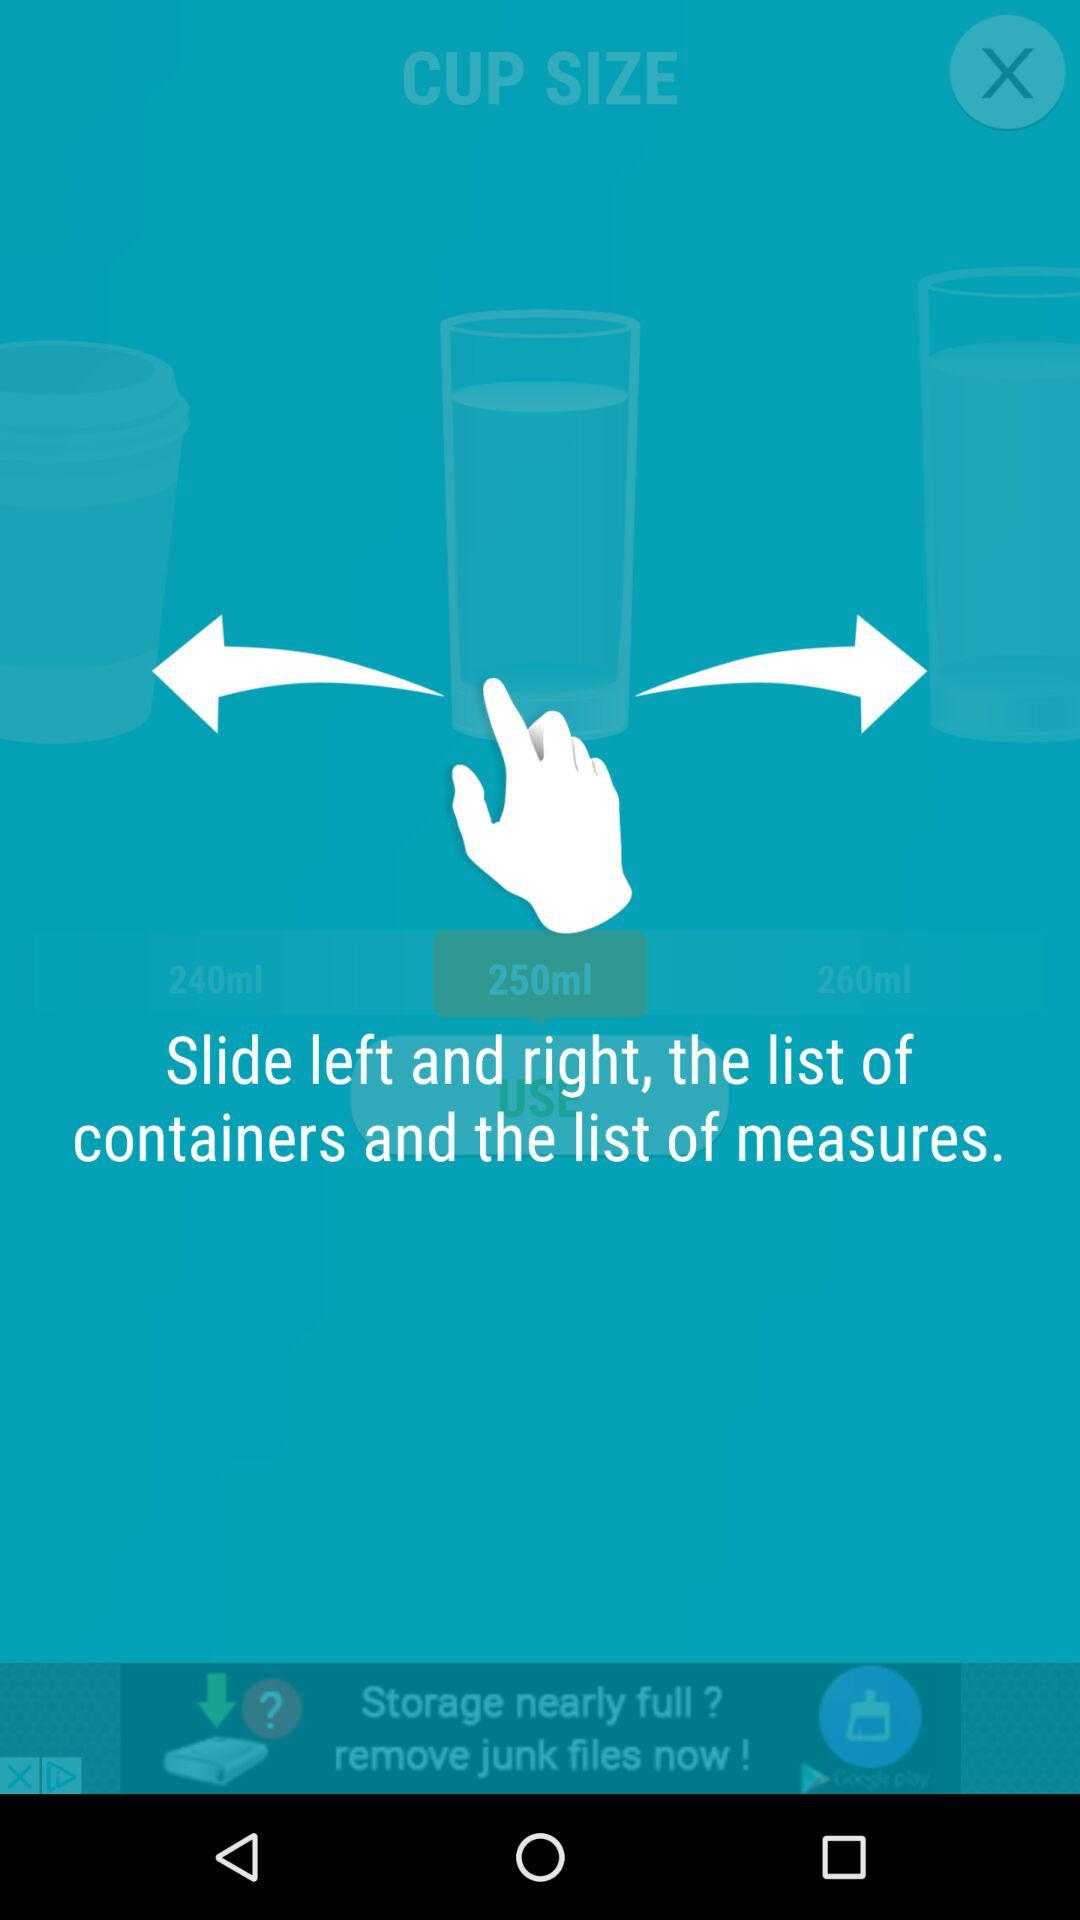How many ml options are there?
Answer the question using a single word or phrase. 3 